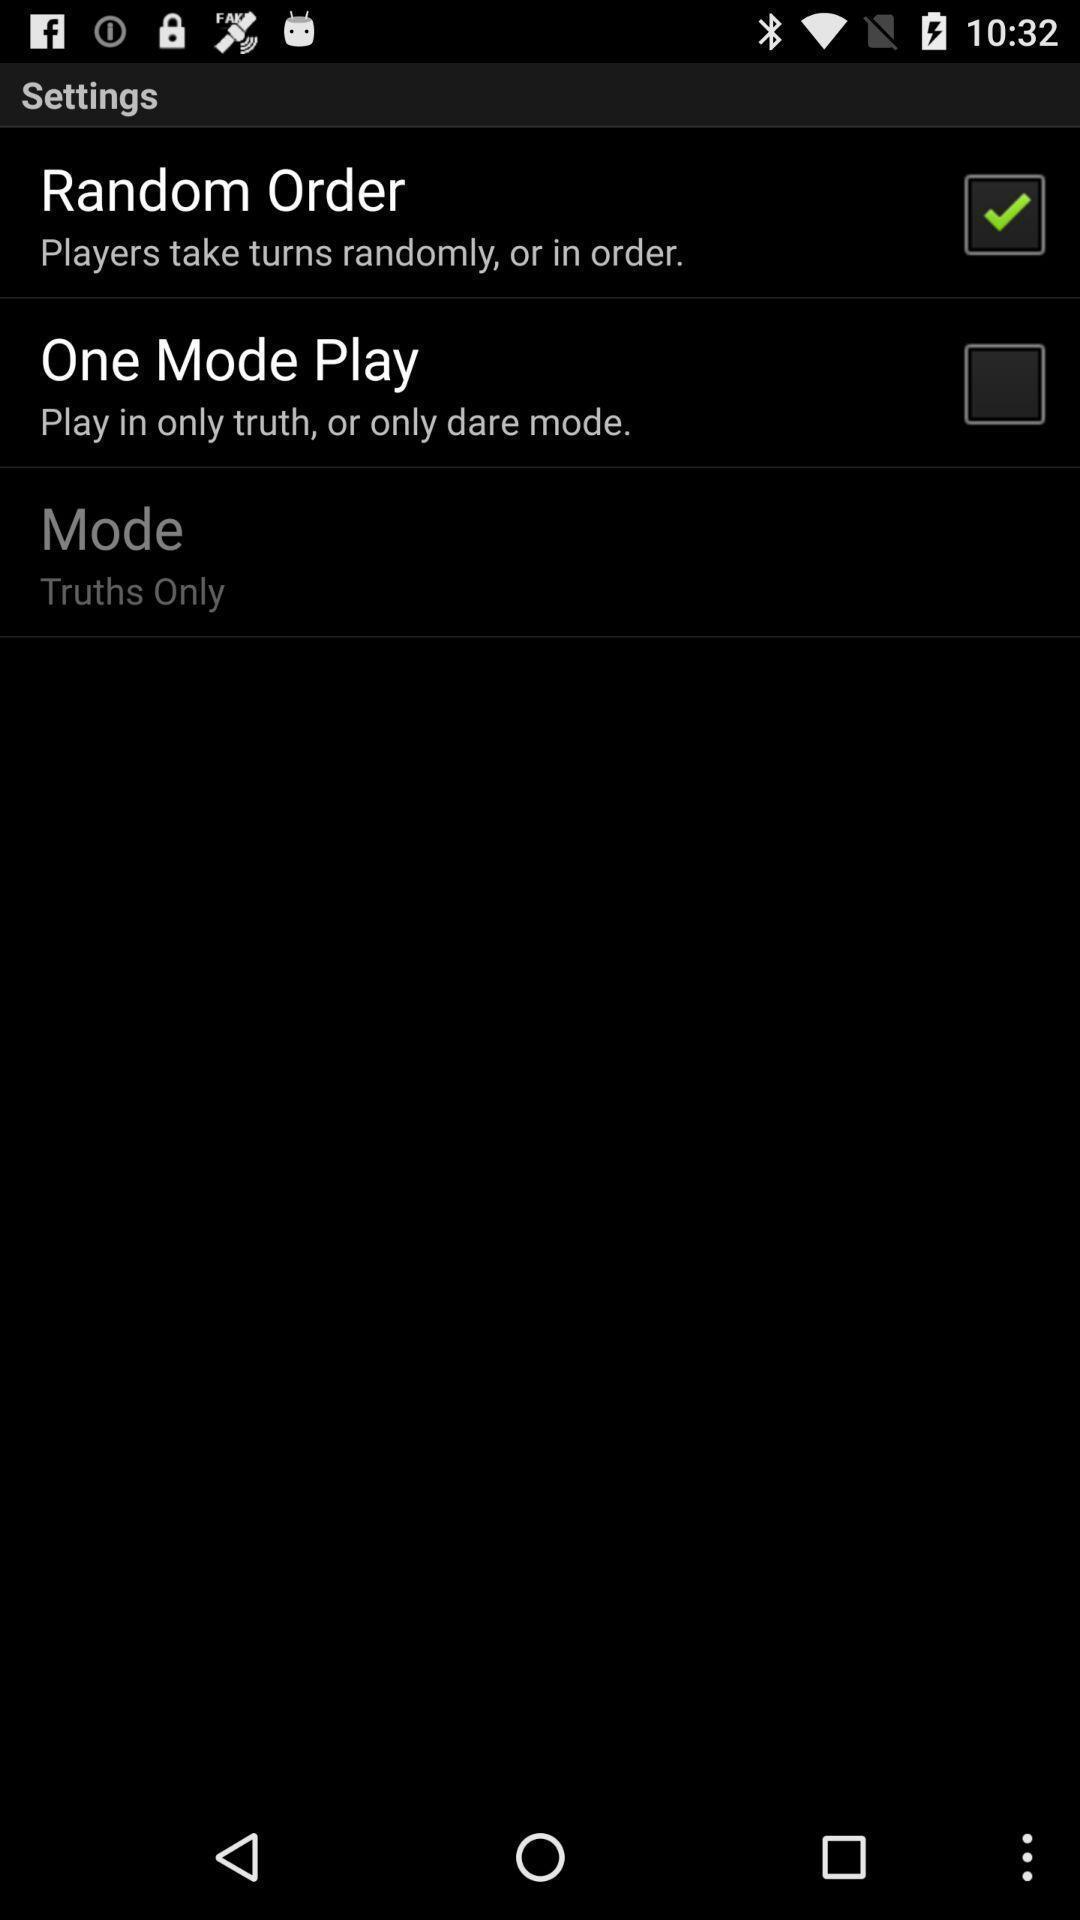Describe the key features of this screenshot. Settings page. 